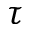<formula> <loc_0><loc_0><loc_500><loc_500>\tau</formula> 